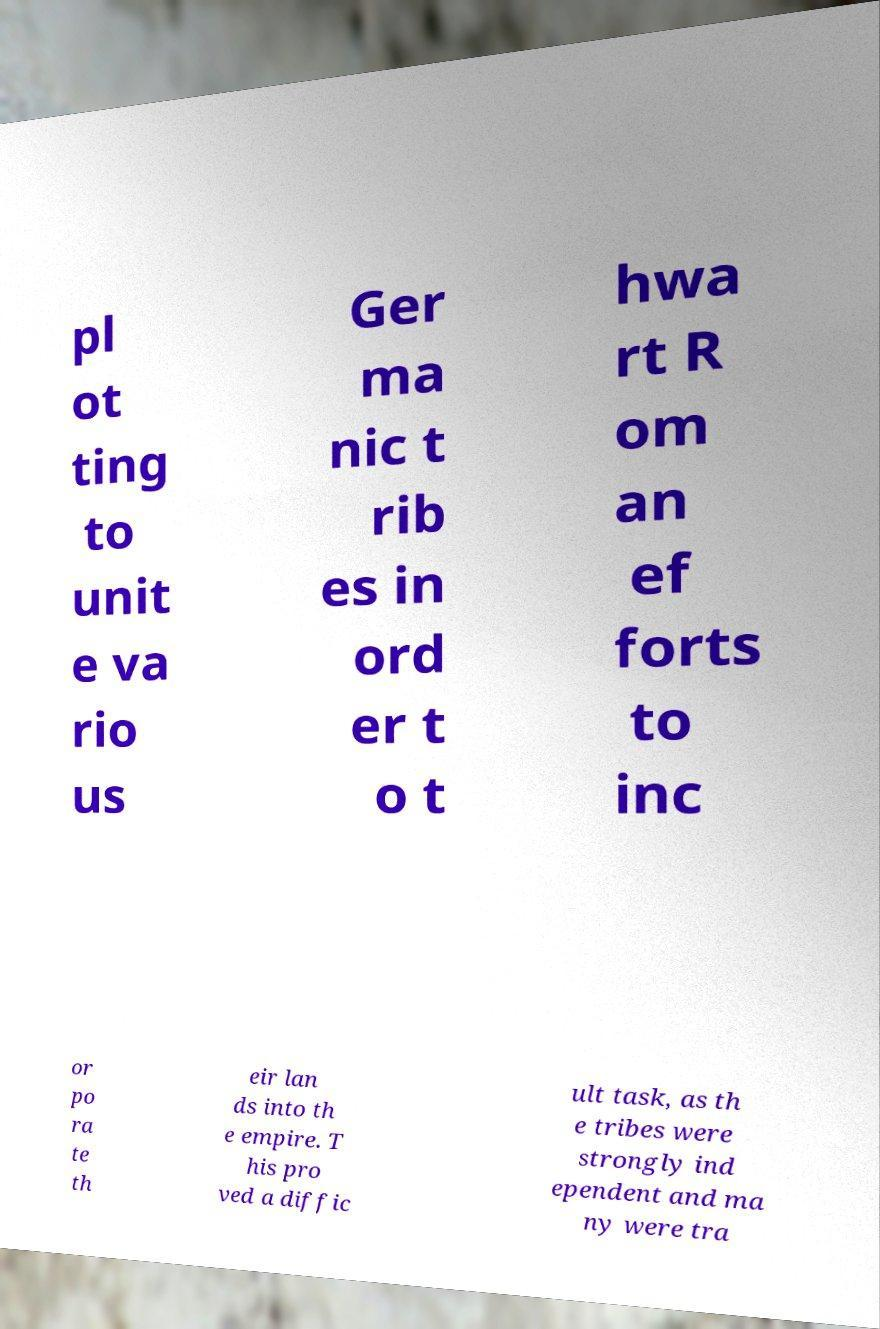Please identify and transcribe the text found in this image. pl ot ting to unit e va rio us Ger ma nic t rib es in ord er t o t hwa rt R om an ef forts to inc or po ra te th eir lan ds into th e empire. T his pro ved a diffic ult task, as th e tribes were strongly ind ependent and ma ny were tra 